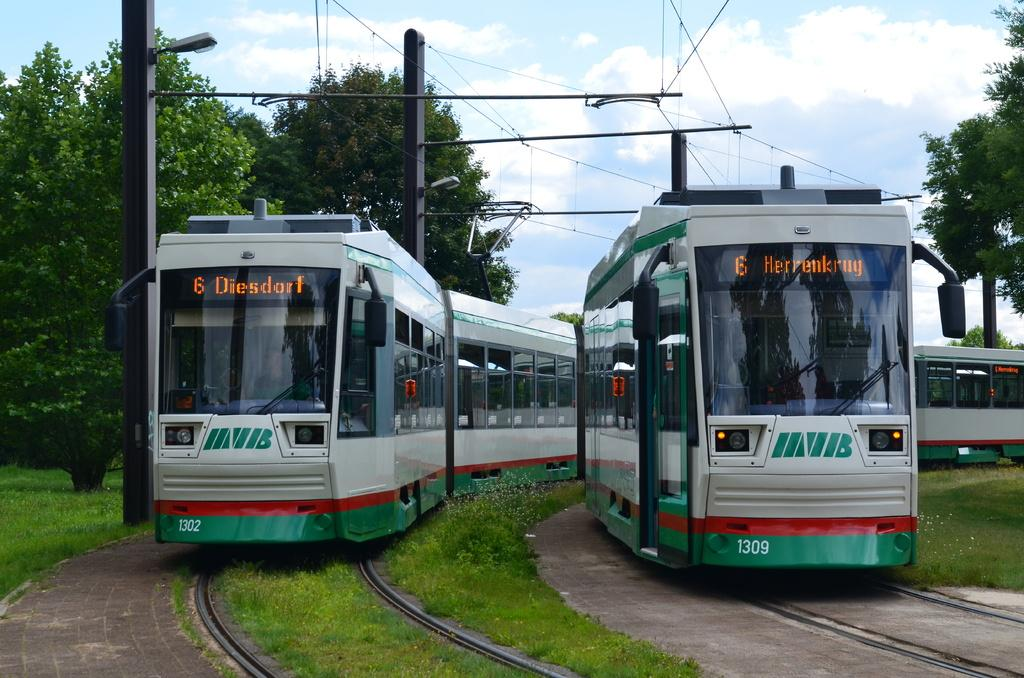How many trains can be seen in the image? There are two trains in the image. Where are the trains located? The trains are on railway tracks. What type of vegetation is visible in the image? There is grass visible in the image. What structures can be seen in the image? There are poles and trees in the image. What is visible in the background of the image? The sky is visible in the background of the image, and clouds are present in the sky. What type of straw is being used by the ants in the image? There are no ants or straws present in the image. What mathematical operation is the calculator performing in the image? There is no calculator present in the image. 